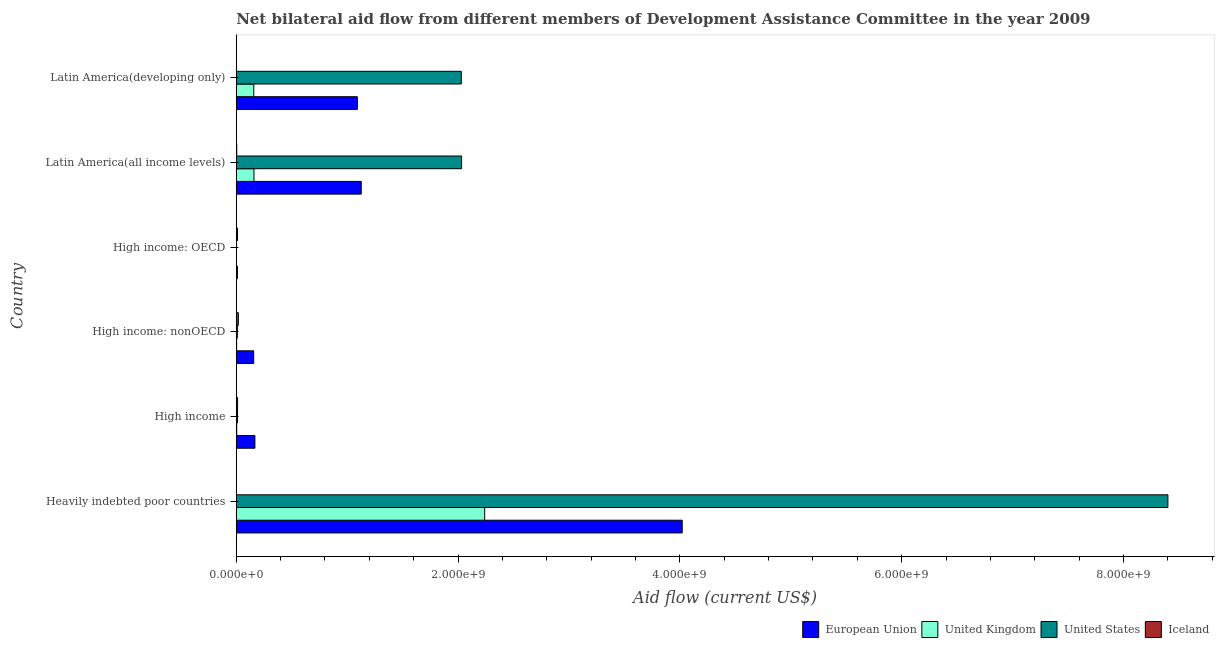Are the number of bars per tick equal to the number of legend labels?
Offer a terse response. Yes. How many bars are there on the 2nd tick from the bottom?
Ensure brevity in your answer.  4. What is the label of the 6th group of bars from the top?
Give a very brief answer. Heavily indebted poor countries. What is the amount of aid given by uk in High income?
Your answer should be very brief. 4.25e+06. Across all countries, what is the maximum amount of aid given by uk?
Offer a terse response. 2.24e+09. Across all countries, what is the minimum amount of aid given by uk?
Your response must be concise. 5.90e+05. In which country was the amount of aid given by eu maximum?
Ensure brevity in your answer.  Heavily indebted poor countries. In which country was the amount of aid given by eu minimum?
Provide a short and direct response. High income: OECD. What is the total amount of aid given by eu in the graph?
Provide a succinct answer. 6.58e+09. What is the difference between the amount of aid given by iceland in Heavily indebted poor countries and that in Latin America(developing only)?
Provide a succinct answer. 2.30e+05. What is the difference between the amount of aid given by eu in High income: nonOECD and the amount of aid given by us in Latin America(developing only)?
Give a very brief answer. -1.87e+09. What is the average amount of aid given by uk per country?
Offer a terse response. 4.28e+08. What is the difference between the amount of aid given by eu and amount of aid given by iceland in High income: nonOECD?
Ensure brevity in your answer.  1.38e+08. In how many countries, is the amount of aid given by eu greater than 1200000000 US$?
Your response must be concise. 1. What is the ratio of the amount of aid given by uk in High income to that in High income: nonOECD?
Your answer should be compact. 1.23. Is the amount of aid given by eu in High income less than that in Latin America(all income levels)?
Provide a short and direct response. Yes. What is the difference between the highest and the second highest amount of aid given by us?
Provide a short and direct response. 6.37e+09. What is the difference between the highest and the lowest amount of aid given by iceland?
Your answer should be compact. 1.76e+07. In how many countries, is the amount of aid given by iceland greater than the average amount of aid given by iceland taken over all countries?
Give a very brief answer. 3. Is the sum of the amount of aid given by us in Heavily indebted poor countries and Latin America(developing only) greater than the maximum amount of aid given by iceland across all countries?
Your answer should be very brief. Yes. What does the 3rd bar from the top in Latin America(developing only) represents?
Your answer should be compact. United Kingdom. Is it the case that in every country, the sum of the amount of aid given by eu and amount of aid given by uk is greater than the amount of aid given by us?
Your response must be concise. No. Are all the bars in the graph horizontal?
Ensure brevity in your answer.  Yes. How many countries are there in the graph?
Offer a very short reply. 6. Are the values on the major ticks of X-axis written in scientific E-notation?
Keep it short and to the point. Yes. Does the graph contain any zero values?
Ensure brevity in your answer.  No. Where does the legend appear in the graph?
Your answer should be very brief. Bottom right. How many legend labels are there?
Your response must be concise. 4. How are the legend labels stacked?
Provide a succinct answer. Horizontal. What is the title of the graph?
Ensure brevity in your answer.  Net bilateral aid flow from different members of Development Assistance Committee in the year 2009. What is the label or title of the Y-axis?
Give a very brief answer. Country. What is the Aid flow (current US$) of European Union in Heavily indebted poor countries?
Provide a succinct answer. 4.02e+09. What is the Aid flow (current US$) in United Kingdom in Heavily indebted poor countries?
Make the answer very short. 2.24e+09. What is the Aid flow (current US$) of United States in Heavily indebted poor countries?
Your answer should be compact. 8.40e+09. What is the Aid flow (current US$) of Iceland in Heavily indebted poor countries?
Provide a succinct answer. 1.67e+06. What is the Aid flow (current US$) in European Union in High income?
Provide a short and direct response. 1.68e+08. What is the Aid flow (current US$) of United Kingdom in High income?
Your answer should be compact. 4.25e+06. What is the Aid flow (current US$) of United States in High income?
Provide a short and direct response. 1.17e+07. What is the Aid flow (current US$) in Iceland in High income?
Keep it short and to the point. 1.21e+07. What is the Aid flow (current US$) of European Union in High income: nonOECD?
Your answer should be compact. 1.57e+08. What is the Aid flow (current US$) in United Kingdom in High income: nonOECD?
Keep it short and to the point. 3.45e+06. What is the Aid flow (current US$) in United States in High income: nonOECD?
Your answer should be very brief. 9.86e+06. What is the Aid flow (current US$) of Iceland in High income: nonOECD?
Give a very brief answer. 1.90e+07. What is the Aid flow (current US$) of European Union in High income: OECD?
Your answer should be compact. 1.08e+07. What is the Aid flow (current US$) of United Kingdom in High income: OECD?
Offer a terse response. 5.90e+05. What is the Aid flow (current US$) of United States in High income: OECD?
Give a very brief answer. 1.84e+06. What is the Aid flow (current US$) of Iceland in High income: OECD?
Keep it short and to the point. 1.17e+07. What is the Aid flow (current US$) of European Union in Latin America(all income levels)?
Provide a short and direct response. 1.13e+09. What is the Aid flow (current US$) in United Kingdom in Latin America(all income levels)?
Make the answer very short. 1.60e+08. What is the Aid flow (current US$) in United States in Latin America(all income levels)?
Your response must be concise. 2.03e+09. What is the Aid flow (current US$) of Iceland in Latin America(all income levels)?
Ensure brevity in your answer.  4.28e+06. What is the Aid flow (current US$) of European Union in Latin America(developing only)?
Offer a terse response. 1.09e+09. What is the Aid flow (current US$) of United Kingdom in Latin America(developing only)?
Give a very brief answer. 1.58e+08. What is the Aid flow (current US$) of United States in Latin America(developing only)?
Your response must be concise. 2.03e+09. What is the Aid flow (current US$) of Iceland in Latin America(developing only)?
Give a very brief answer. 1.44e+06. Across all countries, what is the maximum Aid flow (current US$) in European Union?
Give a very brief answer. 4.02e+09. Across all countries, what is the maximum Aid flow (current US$) of United Kingdom?
Provide a short and direct response. 2.24e+09. Across all countries, what is the maximum Aid flow (current US$) of United States?
Offer a terse response. 8.40e+09. Across all countries, what is the maximum Aid flow (current US$) of Iceland?
Offer a terse response. 1.90e+07. Across all countries, what is the minimum Aid flow (current US$) in European Union?
Your answer should be very brief. 1.08e+07. Across all countries, what is the minimum Aid flow (current US$) in United Kingdom?
Offer a terse response. 5.90e+05. Across all countries, what is the minimum Aid flow (current US$) in United States?
Give a very brief answer. 1.84e+06. Across all countries, what is the minimum Aid flow (current US$) in Iceland?
Provide a short and direct response. 1.44e+06. What is the total Aid flow (current US$) of European Union in the graph?
Give a very brief answer. 6.58e+09. What is the total Aid flow (current US$) in United Kingdom in the graph?
Provide a succinct answer. 2.57e+09. What is the total Aid flow (current US$) in United States in the graph?
Your answer should be compact. 1.25e+1. What is the total Aid flow (current US$) in Iceland in the graph?
Keep it short and to the point. 5.02e+07. What is the difference between the Aid flow (current US$) in European Union in Heavily indebted poor countries and that in High income?
Your response must be concise. 3.85e+09. What is the difference between the Aid flow (current US$) in United Kingdom in Heavily indebted poor countries and that in High income?
Your answer should be very brief. 2.24e+09. What is the difference between the Aid flow (current US$) of United States in Heavily indebted poor countries and that in High income?
Keep it short and to the point. 8.39e+09. What is the difference between the Aid flow (current US$) of Iceland in Heavily indebted poor countries and that in High income?
Offer a very short reply. -1.04e+07. What is the difference between the Aid flow (current US$) in European Union in Heavily indebted poor countries and that in High income: nonOECD?
Your answer should be very brief. 3.86e+09. What is the difference between the Aid flow (current US$) of United Kingdom in Heavily indebted poor countries and that in High income: nonOECD?
Your response must be concise. 2.24e+09. What is the difference between the Aid flow (current US$) of United States in Heavily indebted poor countries and that in High income: nonOECD?
Ensure brevity in your answer.  8.39e+09. What is the difference between the Aid flow (current US$) in Iceland in Heavily indebted poor countries and that in High income: nonOECD?
Keep it short and to the point. -1.74e+07. What is the difference between the Aid flow (current US$) in European Union in Heavily indebted poor countries and that in High income: OECD?
Provide a succinct answer. 4.01e+09. What is the difference between the Aid flow (current US$) in United Kingdom in Heavily indebted poor countries and that in High income: OECD?
Offer a terse response. 2.24e+09. What is the difference between the Aid flow (current US$) of United States in Heavily indebted poor countries and that in High income: OECD?
Your response must be concise. 8.40e+09. What is the difference between the Aid flow (current US$) in Iceland in Heavily indebted poor countries and that in High income: OECD?
Your answer should be compact. -9.99e+06. What is the difference between the Aid flow (current US$) in European Union in Heavily indebted poor countries and that in Latin America(all income levels)?
Keep it short and to the point. 2.89e+09. What is the difference between the Aid flow (current US$) in United Kingdom in Heavily indebted poor countries and that in Latin America(all income levels)?
Your response must be concise. 2.08e+09. What is the difference between the Aid flow (current US$) in United States in Heavily indebted poor countries and that in Latin America(all income levels)?
Provide a succinct answer. 6.37e+09. What is the difference between the Aid flow (current US$) in Iceland in Heavily indebted poor countries and that in Latin America(all income levels)?
Your answer should be compact. -2.61e+06. What is the difference between the Aid flow (current US$) of European Union in Heavily indebted poor countries and that in Latin America(developing only)?
Offer a very short reply. 2.93e+09. What is the difference between the Aid flow (current US$) of United Kingdom in Heavily indebted poor countries and that in Latin America(developing only)?
Give a very brief answer. 2.08e+09. What is the difference between the Aid flow (current US$) in United States in Heavily indebted poor countries and that in Latin America(developing only)?
Provide a succinct answer. 6.37e+09. What is the difference between the Aid flow (current US$) of European Union in High income and that in High income: nonOECD?
Ensure brevity in your answer.  1.08e+07. What is the difference between the Aid flow (current US$) in United Kingdom in High income and that in High income: nonOECD?
Offer a terse response. 8.00e+05. What is the difference between the Aid flow (current US$) of United States in High income and that in High income: nonOECD?
Keep it short and to the point. 1.84e+06. What is the difference between the Aid flow (current US$) of Iceland in High income and that in High income: nonOECD?
Offer a terse response. -6.97e+06. What is the difference between the Aid flow (current US$) of European Union in High income and that in High income: OECD?
Your answer should be compact. 1.57e+08. What is the difference between the Aid flow (current US$) in United Kingdom in High income and that in High income: OECD?
Make the answer very short. 3.66e+06. What is the difference between the Aid flow (current US$) of United States in High income and that in High income: OECD?
Provide a short and direct response. 9.86e+06. What is the difference between the Aid flow (current US$) in European Union in High income and that in Latin America(all income levels)?
Give a very brief answer. -9.59e+08. What is the difference between the Aid flow (current US$) in United Kingdom in High income and that in Latin America(all income levels)?
Provide a succinct answer. -1.55e+08. What is the difference between the Aid flow (current US$) in United States in High income and that in Latin America(all income levels)?
Offer a very short reply. -2.02e+09. What is the difference between the Aid flow (current US$) in Iceland in High income and that in Latin America(all income levels)?
Your response must be concise. 7.79e+06. What is the difference between the Aid flow (current US$) in European Union in High income and that in Latin America(developing only)?
Provide a short and direct response. -9.24e+08. What is the difference between the Aid flow (current US$) in United Kingdom in High income and that in Latin America(developing only)?
Offer a terse response. -1.54e+08. What is the difference between the Aid flow (current US$) in United States in High income and that in Latin America(developing only)?
Make the answer very short. -2.02e+09. What is the difference between the Aid flow (current US$) in Iceland in High income and that in Latin America(developing only)?
Your answer should be very brief. 1.06e+07. What is the difference between the Aid flow (current US$) of European Union in High income: nonOECD and that in High income: OECD?
Offer a very short reply. 1.47e+08. What is the difference between the Aid flow (current US$) of United Kingdom in High income: nonOECD and that in High income: OECD?
Your response must be concise. 2.86e+06. What is the difference between the Aid flow (current US$) in United States in High income: nonOECD and that in High income: OECD?
Offer a very short reply. 8.02e+06. What is the difference between the Aid flow (current US$) in Iceland in High income: nonOECD and that in High income: OECD?
Your response must be concise. 7.38e+06. What is the difference between the Aid flow (current US$) of European Union in High income: nonOECD and that in Latin America(all income levels)?
Give a very brief answer. -9.70e+08. What is the difference between the Aid flow (current US$) of United Kingdom in High income: nonOECD and that in Latin America(all income levels)?
Offer a very short reply. -1.56e+08. What is the difference between the Aid flow (current US$) in United States in High income: nonOECD and that in Latin America(all income levels)?
Offer a very short reply. -2.02e+09. What is the difference between the Aid flow (current US$) of Iceland in High income: nonOECD and that in Latin America(all income levels)?
Give a very brief answer. 1.48e+07. What is the difference between the Aid flow (current US$) in European Union in High income: nonOECD and that in Latin America(developing only)?
Offer a terse response. -9.35e+08. What is the difference between the Aid flow (current US$) in United Kingdom in High income: nonOECD and that in Latin America(developing only)?
Offer a terse response. -1.55e+08. What is the difference between the Aid flow (current US$) in United States in High income: nonOECD and that in Latin America(developing only)?
Give a very brief answer. -2.02e+09. What is the difference between the Aid flow (current US$) of Iceland in High income: nonOECD and that in Latin America(developing only)?
Your answer should be very brief. 1.76e+07. What is the difference between the Aid flow (current US$) of European Union in High income: OECD and that in Latin America(all income levels)?
Your response must be concise. -1.12e+09. What is the difference between the Aid flow (current US$) of United Kingdom in High income: OECD and that in Latin America(all income levels)?
Provide a succinct answer. -1.59e+08. What is the difference between the Aid flow (current US$) in United States in High income: OECD and that in Latin America(all income levels)?
Provide a short and direct response. -2.03e+09. What is the difference between the Aid flow (current US$) of Iceland in High income: OECD and that in Latin America(all income levels)?
Your answer should be compact. 7.38e+06. What is the difference between the Aid flow (current US$) in European Union in High income: OECD and that in Latin America(developing only)?
Offer a very short reply. -1.08e+09. What is the difference between the Aid flow (current US$) of United Kingdom in High income: OECD and that in Latin America(developing only)?
Give a very brief answer. -1.57e+08. What is the difference between the Aid flow (current US$) in United States in High income: OECD and that in Latin America(developing only)?
Provide a succinct answer. -2.03e+09. What is the difference between the Aid flow (current US$) in Iceland in High income: OECD and that in Latin America(developing only)?
Ensure brevity in your answer.  1.02e+07. What is the difference between the Aid flow (current US$) of European Union in Latin America(all income levels) and that in Latin America(developing only)?
Give a very brief answer. 3.50e+07. What is the difference between the Aid flow (current US$) of United Kingdom in Latin America(all income levels) and that in Latin America(developing only)?
Make the answer very short. 1.74e+06. What is the difference between the Aid flow (current US$) of United States in Latin America(all income levels) and that in Latin America(developing only)?
Keep it short and to the point. 2.58e+06. What is the difference between the Aid flow (current US$) in Iceland in Latin America(all income levels) and that in Latin America(developing only)?
Offer a terse response. 2.84e+06. What is the difference between the Aid flow (current US$) of European Union in Heavily indebted poor countries and the Aid flow (current US$) of United Kingdom in High income?
Provide a short and direct response. 4.02e+09. What is the difference between the Aid flow (current US$) of European Union in Heavily indebted poor countries and the Aid flow (current US$) of United States in High income?
Make the answer very short. 4.01e+09. What is the difference between the Aid flow (current US$) of European Union in Heavily indebted poor countries and the Aid flow (current US$) of Iceland in High income?
Offer a very short reply. 4.01e+09. What is the difference between the Aid flow (current US$) in United Kingdom in Heavily indebted poor countries and the Aid flow (current US$) in United States in High income?
Your response must be concise. 2.23e+09. What is the difference between the Aid flow (current US$) of United Kingdom in Heavily indebted poor countries and the Aid flow (current US$) of Iceland in High income?
Keep it short and to the point. 2.23e+09. What is the difference between the Aid flow (current US$) of United States in Heavily indebted poor countries and the Aid flow (current US$) of Iceland in High income?
Give a very brief answer. 8.39e+09. What is the difference between the Aid flow (current US$) of European Union in Heavily indebted poor countries and the Aid flow (current US$) of United Kingdom in High income: nonOECD?
Make the answer very short. 4.02e+09. What is the difference between the Aid flow (current US$) in European Union in Heavily indebted poor countries and the Aid flow (current US$) in United States in High income: nonOECD?
Offer a terse response. 4.01e+09. What is the difference between the Aid flow (current US$) in European Union in Heavily indebted poor countries and the Aid flow (current US$) in Iceland in High income: nonOECD?
Your answer should be compact. 4.00e+09. What is the difference between the Aid flow (current US$) in United Kingdom in Heavily indebted poor countries and the Aid flow (current US$) in United States in High income: nonOECD?
Your answer should be very brief. 2.23e+09. What is the difference between the Aid flow (current US$) of United Kingdom in Heavily indebted poor countries and the Aid flow (current US$) of Iceland in High income: nonOECD?
Offer a terse response. 2.22e+09. What is the difference between the Aid flow (current US$) of United States in Heavily indebted poor countries and the Aid flow (current US$) of Iceland in High income: nonOECD?
Offer a terse response. 8.38e+09. What is the difference between the Aid flow (current US$) in European Union in Heavily indebted poor countries and the Aid flow (current US$) in United Kingdom in High income: OECD?
Your response must be concise. 4.02e+09. What is the difference between the Aid flow (current US$) in European Union in Heavily indebted poor countries and the Aid flow (current US$) in United States in High income: OECD?
Keep it short and to the point. 4.02e+09. What is the difference between the Aid flow (current US$) of European Union in Heavily indebted poor countries and the Aid flow (current US$) of Iceland in High income: OECD?
Ensure brevity in your answer.  4.01e+09. What is the difference between the Aid flow (current US$) of United Kingdom in Heavily indebted poor countries and the Aid flow (current US$) of United States in High income: OECD?
Give a very brief answer. 2.24e+09. What is the difference between the Aid flow (current US$) in United Kingdom in Heavily indebted poor countries and the Aid flow (current US$) in Iceland in High income: OECD?
Your response must be concise. 2.23e+09. What is the difference between the Aid flow (current US$) in United States in Heavily indebted poor countries and the Aid flow (current US$) in Iceland in High income: OECD?
Keep it short and to the point. 8.39e+09. What is the difference between the Aid flow (current US$) of European Union in Heavily indebted poor countries and the Aid flow (current US$) of United Kingdom in Latin America(all income levels)?
Ensure brevity in your answer.  3.86e+09. What is the difference between the Aid flow (current US$) of European Union in Heavily indebted poor countries and the Aid flow (current US$) of United States in Latin America(all income levels)?
Your answer should be very brief. 1.99e+09. What is the difference between the Aid flow (current US$) in European Union in Heavily indebted poor countries and the Aid flow (current US$) in Iceland in Latin America(all income levels)?
Ensure brevity in your answer.  4.02e+09. What is the difference between the Aid flow (current US$) of United Kingdom in Heavily indebted poor countries and the Aid flow (current US$) of United States in Latin America(all income levels)?
Provide a succinct answer. 2.08e+08. What is the difference between the Aid flow (current US$) of United Kingdom in Heavily indebted poor countries and the Aid flow (current US$) of Iceland in Latin America(all income levels)?
Provide a succinct answer. 2.24e+09. What is the difference between the Aid flow (current US$) of United States in Heavily indebted poor countries and the Aid flow (current US$) of Iceland in Latin America(all income levels)?
Your answer should be compact. 8.40e+09. What is the difference between the Aid flow (current US$) of European Union in Heavily indebted poor countries and the Aid flow (current US$) of United Kingdom in Latin America(developing only)?
Your answer should be very brief. 3.86e+09. What is the difference between the Aid flow (current US$) in European Union in Heavily indebted poor countries and the Aid flow (current US$) in United States in Latin America(developing only)?
Give a very brief answer. 1.99e+09. What is the difference between the Aid flow (current US$) of European Union in Heavily indebted poor countries and the Aid flow (current US$) of Iceland in Latin America(developing only)?
Offer a terse response. 4.02e+09. What is the difference between the Aid flow (current US$) of United Kingdom in Heavily indebted poor countries and the Aid flow (current US$) of United States in Latin America(developing only)?
Ensure brevity in your answer.  2.11e+08. What is the difference between the Aid flow (current US$) of United Kingdom in Heavily indebted poor countries and the Aid flow (current US$) of Iceland in Latin America(developing only)?
Give a very brief answer. 2.24e+09. What is the difference between the Aid flow (current US$) in United States in Heavily indebted poor countries and the Aid flow (current US$) in Iceland in Latin America(developing only)?
Ensure brevity in your answer.  8.40e+09. What is the difference between the Aid flow (current US$) in European Union in High income and the Aid flow (current US$) in United Kingdom in High income: nonOECD?
Make the answer very short. 1.65e+08. What is the difference between the Aid flow (current US$) of European Union in High income and the Aid flow (current US$) of United States in High income: nonOECD?
Provide a succinct answer. 1.58e+08. What is the difference between the Aid flow (current US$) in European Union in High income and the Aid flow (current US$) in Iceland in High income: nonOECD?
Offer a very short reply. 1.49e+08. What is the difference between the Aid flow (current US$) in United Kingdom in High income and the Aid flow (current US$) in United States in High income: nonOECD?
Your response must be concise. -5.61e+06. What is the difference between the Aid flow (current US$) in United Kingdom in High income and the Aid flow (current US$) in Iceland in High income: nonOECD?
Offer a terse response. -1.48e+07. What is the difference between the Aid flow (current US$) in United States in High income and the Aid flow (current US$) in Iceland in High income: nonOECD?
Ensure brevity in your answer.  -7.34e+06. What is the difference between the Aid flow (current US$) in European Union in High income and the Aid flow (current US$) in United Kingdom in High income: OECD?
Provide a succinct answer. 1.68e+08. What is the difference between the Aid flow (current US$) in European Union in High income and the Aid flow (current US$) in United States in High income: OECD?
Ensure brevity in your answer.  1.66e+08. What is the difference between the Aid flow (current US$) of European Union in High income and the Aid flow (current US$) of Iceland in High income: OECD?
Ensure brevity in your answer.  1.56e+08. What is the difference between the Aid flow (current US$) of United Kingdom in High income and the Aid flow (current US$) of United States in High income: OECD?
Make the answer very short. 2.41e+06. What is the difference between the Aid flow (current US$) in United Kingdom in High income and the Aid flow (current US$) in Iceland in High income: OECD?
Provide a short and direct response. -7.41e+06. What is the difference between the Aid flow (current US$) in United States in High income and the Aid flow (current US$) in Iceland in High income: OECD?
Offer a terse response. 4.00e+04. What is the difference between the Aid flow (current US$) of European Union in High income and the Aid flow (current US$) of United Kingdom in Latin America(all income levels)?
Offer a terse response. 8.38e+06. What is the difference between the Aid flow (current US$) in European Union in High income and the Aid flow (current US$) in United States in Latin America(all income levels)?
Ensure brevity in your answer.  -1.86e+09. What is the difference between the Aid flow (current US$) of European Union in High income and the Aid flow (current US$) of Iceland in Latin America(all income levels)?
Your answer should be compact. 1.64e+08. What is the difference between the Aid flow (current US$) in United Kingdom in High income and the Aid flow (current US$) in United States in Latin America(all income levels)?
Provide a succinct answer. -2.03e+09. What is the difference between the Aid flow (current US$) in United States in High income and the Aid flow (current US$) in Iceland in Latin America(all income levels)?
Provide a succinct answer. 7.42e+06. What is the difference between the Aid flow (current US$) in European Union in High income and the Aid flow (current US$) in United Kingdom in Latin America(developing only)?
Offer a terse response. 1.01e+07. What is the difference between the Aid flow (current US$) of European Union in High income and the Aid flow (current US$) of United States in Latin America(developing only)?
Your answer should be very brief. -1.86e+09. What is the difference between the Aid flow (current US$) in European Union in High income and the Aid flow (current US$) in Iceland in Latin America(developing only)?
Your answer should be very brief. 1.67e+08. What is the difference between the Aid flow (current US$) of United Kingdom in High income and the Aid flow (current US$) of United States in Latin America(developing only)?
Give a very brief answer. -2.02e+09. What is the difference between the Aid flow (current US$) in United Kingdom in High income and the Aid flow (current US$) in Iceland in Latin America(developing only)?
Ensure brevity in your answer.  2.81e+06. What is the difference between the Aid flow (current US$) in United States in High income and the Aid flow (current US$) in Iceland in Latin America(developing only)?
Give a very brief answer. 1.03e+07. What is the difference between the Aid flow (current US$) in European Union in High income: nonOECD and the Aid flow (current US$) in United Kingdom in High income: OECD?
Your answer should be compact. 1.57e+08. What is the difference between the Aid flow (current US$) of European Union in High income: nonOECD and the Aid flow (current US$) of United States in High income: OECD?
Offer a terse response. 1.55e+08. What is the difference between the Aid flow (current US$) in European Union in High income: nonOECD and the Aid flow (current US$) in Iceland in High income: OECD?
Give a very brief answer. 1.46e+08. What is the difference between the Aid flow (current US$) of United Kingdom in High income: nonOECD and the Aid flow (current US$) of United States in High income: OECD?
Offer a terse response. 1.61e+06. What is the difference between the Aid flow (current US$) of United Kingdom in High income: nonOECD and the Aid flow (current US$) of Iceland in High income: OECD?
Your answer should be very brief. -8.21e+06. What is the difference between the Aid flow (current US$) of United States in High income: nonOECD and the Aid flow (current US$) of Iceland in High income: OECD?
Ensure brevity in your answer.  -1.80e+06. What is the difference between the Aid flow (current US$) in European Union in High income: nonOECD and the Aid flow (current US$) in United Kingdom in Latin America(all income levels)?
Provide a short and direct response. -2.42e+06. What is the difference between the Aid flow (current US$) of European Union in High income: nonOECD and the Aid flow (current US$) of United States in Latin America(all income levels)?
Offer a very short reply. -1.87e+09. What is the difference between the Aid flow (current US$) in European Union in High income: nonOECD and the Aid flow (current US$) in Iceland in Latin America(all income levels)?
Ensure brevity in your answer.  1.53e+08. What is the difference between the Aid flow (current US$) in United Kingdom in High income: nonOECD and the Aid flow (current US$) in United States in Latin America(all income levels)?
Provide a succinct answer. -2.03e+09. What is the difference between the Aid flow (current US$) in United Kingdom in High income: nonOECD and the Aid flow (current US$) in Iceland in Latin America(all income levels)?
Your answer should be very brief. -8.30e+05. What is the difference between the Aid flow (current US$) in United States in High income: nonOECD and the Aid flow (current US$) in Iceland in Latin America(all income levels)?
Your answer should be compact. 5.58e+06. What is the difference between the Aid flow (current US$) in European Union in High income: nonOECD and the Aid flow (current US$) in United Kingdom in Latin America(developing only)?
Keep it short and to the point. -6.80e+05. What is the difference between the Aid flow (current US$) in European Union in High income: nonOECD and the Aid flow (current US$) in United States in Latin America(developing only)?
Ensure brevity in your answer.  -1.87e+09. What is the difference between the Aid flow (current US$) of European Union in High income: nonOECD and the Aid flow (current US$) of Iceland in Latin America(developing only)?
Keep it short and to the point. 1.56e+08. What is the difference between the Aid flow (current US$) of United Kingdom in High income: nonOECD and the Aid flow (current US$) of United States in Latin America(developing only)?
Ensure brevity in your answer.  -2.03e+09. What is the difference between the Aid flow (current US$) of United Kingdom in High income: nonOECD and the Aid flow (current US$) of Iceland in Latin America(developing only)?
Provide a succinct answer. 2.01e+06. What is the difference between the Aid flow (current US$) in United States in High income: nonOECD and the Aid flow (current US$) in Iceland in Latin America(developing only)?
Offer a terse response. 8.42e+06. What is the difference between the Aid flow (current US$) of European Union in High income: OECD and the Aid flow (current US$) of United Kingdom in Latin America(all income levels)?
Provide a short and direct response. -1.49e+08. What is the difference between the Aid flow (current US$) of European Union in High income: OECD and the Aid flow (current US$) of United States in Latin America(all income levels)?
Your answer should be compact. -2.02e+09. What is the difference between the Aid flow (current US$) of European Union in High income: OECD and the Aid flow (current US$) of Iceland in Latin America(all income levels)?
Keep it short and to the point. 6.52e+06. What is the difference between the Aid flow (current US$) in United Kingdom in High income: OECD and the Aid flow (current US$) in United States in Latin America(all income levels)?
Your response must be concise. -2.03e+09. What is the difference between the Aid flow (current US$) of United Kingdom in High income: OECD and the Aid flow (current US$) of Iceland in Latin America(all income levels)?
Provide a succinct answer. -3.69e+06. What is the difference between the Aid flow (current US$) in United States in High income: OECD and the Aid flow (current US$) in Iceland in Latin America(all income levels)?
Offer a terse response. -2.44e+06. What is the difference between the Aid flow (current US$) in European Union in High income: OECD and the Aid flow (current US$) in United Kingdom in Latin America(developing only)?
Give a very brief answer. -1.47e+08. What is the difference between the Aid flow (current US$) in European Union in High income: OECD and the Aid flow (current US$) in United States in Latin America(developing only)?
Offer a terse response. -2.02e+09. What is the difference between the Aid flow (current US$) of European Union in High income: OECD and the Aid flow (current US$) of Iceland in Latin America(developing only)?
Offer a terse response. 9.36e+06. What is the difference between the Aid flow (current US$) in United Kingdom in High income: OECD and the Aid flow (current US$) in United States in Latin America(developing only)?
Make the answer very short. -2.03e+09. What is the difference between the Aid flow (current US$) in United Kingdom in High income: OECD and the Aid flow (current US$) in Iceland in Latin America(developing only)?
Offer a very short reply. -8.50e+05. What is the difference between the Aid flow (current US$) of United States in High income: OECD and the Aid flow (current US$) of Iceland in Latin America(developing only)?
Your answer should be compact. 4.00e+05. What is the difference between the Aid flow (current US$) in European Union in Latin America(all income levels) and the Aid flow (current US$) in United Kingdom in Latin America(developing only)?
Your answer should be compact. 9.69e+08. What is the difference between the Aid flow (current US$) of European Union in Latin America(all income levels) and the Aid flow (current US$) of United States in Latin America(developing only)?
Ensure brevity in your answer.  -9.02e+08. What is the difference between the Aid flow (current US$) in European Union in Latin America(all income levels) and the Aid flow (current US$) in Iceland in Latin America(developing only)?
Keep it short and to the point. 1.13e+09. What is the difference between the Aid flow (current US$) of United Kingdom in Latin America(all income levels) and the Aid flow (current US$) of United States in Latin America(developing only)?
Your answer should be compact. -1.87e+09. What is the difference between the Aid flow (current US$) of United Kingdom in Latin America(all income levels) and the Aid flow (current US$) of Iceland in Latin America(developing only)?
Offer a very short reply. 1.58e+08. What is the difference between the Aid flow (current US$) in United States in Latin America(all income levels) and the Aid flow (current US$) in Iceland in Latin America(developing only)?
Offer a terse response. 2.03e+09. What is the average Aid flow (current US$) of European Union per country?
Make the answer very short. 1.10e+09. What is the average Aid flow (current US$) of United Kingdom per country?
Your response must be concise. 4.28e+08. What is the average Aid flow (current US$) in United States per country?
Provide a short and direct response. 2.08e+09. What is the average Aid flow (current US$) in Iceland per country?
Make the answer very short. 8.36e+06. What is the difference between the Aid flow (current US$) in European Union and Aid flow (current US$) in United Kingdom in Heavily indebted poor countries?
Provide a succinct answer. 1.78e+09. What is the difference between the Aid flow (current US$) of European Union and Aid flow (current US$) of United States in Heavily indebted poor countries?
Your answer should be compact. -4.38e+09. What is the difference between the Aid flow (current US$) in European Union and Aid flow (current US$) in Iceland in Heavily indebted poor countries?
Offer a very short reply. 4.02e+09. What is the difference between the Aid flow (current US$) of United Kingdom and Aid flow (current US$) of United States in Heavily indebted poor countries?
Your answer should be compact. -6.16e+09. What is the difference between the Aid flow (current US$) of United Kingdom and Aid flow (current US$) of Iceland in Heavily indebted poor countries?
Give a very brief answer. 2.24e+09. What is the difference between the Aid flow (current US$) in United States and Aid flow (current US$) in Iceland in Heavily indebted poor countries?
Your response must be concise. 8.40e+09. What is the difference between the Aid flow (current US$) in European Union and Aid flow (current US$) in United Kingdom in High income?
Offer a terse response. 1.64e+08. What is the difference between the Aid flow (current US$) in European Union and Aid flow (current US$) in United States in High income?
Your answer should be very brief. 1.56e+08. What is the difference between the Aid flow (current US$) in European Union and Aid flow (current US$) in Iceland in High income?
Offer a terse response. 1.56e+08. What is the difference between the Aid flow (current US$) of United Kingdom and Aid flow (current US$) of United States in High income?
Ensure brevity in your answer.  -7.45e+06. What is the difference between the Aid flow (current US$) in United Kingdom and Aid flow (current US$) in Iceland in High income?
Give a very brief answer. -7.82e+06. What is the difference between the Aid flow (current US$) in United States and Aid flow (current US$) in Iceland in High income?
Provide a succinct answer. -3.70e+05. What is the difference between the Aid flow (current US$) of European Union and Aid flow (current US$) of United Kingdom in High income: nonOECD?
Your answer should be very brief. 1.54e+08. What is the difference between the Aid flow (current US$) in European Union and Aid flow (current US$) in United States in High income: nonOECD?
Your answer should be compact. 1.47e+08. What is the difference between the Aid flow (current US$) of European Union and Aid flow (current US$) of Iceland in High income: nonOECD?
Make the answer very short. 1.38e+08. What is the difference between the Aid flow (current US$) of United Kingdom and Aid flow (current US$) of United States in High income: nonOECD?
Keep it short and to the point. -6.41e+06. What is the difference between the Aid flow (current US$) of United Kingdom and Aid flow (current US$) of Iceland in High income: nonOECD?
Ensure brevity in your answer.  -1.56e+07. What is the difference between the Aid flow (current US$) of United States and Aid flow (current US$) of Iceland in High income: nonOECD?
Your answer should be very brief. -9.18e+06. What is the difference between the Aid flow (current US$) in European Union and Aid flow (current US$) in United Kingdom in High income: OECD?
Offer a very short reply. 1.02e+07. What is the difference between the Aid flow (current US$) in European Union and Aid flow (current US$) in United States in High income: OECD?
Make the answer very short. 8.96e+06. What is the difference between the Aid flow (current US$) in European Union and Aid flow (current US$) in Iceland in High income: OECD?
Provide a succinct answer. -8.60e+05. What is the difference between the Aid flow (current US$) of United Kingdom and Aid flow (current US$) of United States in High income: OECD?
Your answer should be very brief. -1.25e+06. What is the difference between the Aid flow (current US$) in United Kingdom and Aid flow (current US$) in Iceland in High income: OECD?
Offer a terse response. -1.11e+07. What is the difference between the Aid flow (current US$) in United States and Aid flow (current US$) in Iceland in High income: OECD?
Your answer should be very brief. -9.82e+06. What is the difference between the Aid flow (current US$) of European Union and Aid flow (current US$) of United Kingdom in Latin America(all income levels)?
Offer a terse response. 9.67e+08. What is the difference between the Aid flow (current US$) in European Union and Aid flow (current US$) in United States in Latin America(all income levels)?
Ensure brevity in your answer.  -9.05e+08. What is the difference between the Aid flow (current US$) in European Union and Aid flow (current US$) in Iceland in Latin America(all income levels)?
Your response must be concise. 1.12e+09. What is the difference between the Aid flow (current US$) in United Kingdom and Aid flow (current US$) in United States in Latin America(all income levels)?
Ensure brevity in your answer.  -1.87e+09. What is the difference between the Aid flow (current US$) of United Kingdom and Aid flow (current US$) of Iceland in Latin America(all income levels)?
Your response must be concise. 1.55e+08. What is the difference between the Aid flow (current US$) of United States and Aid flow (current US$) of Iceland in Latin America(all income levels)?
Provide a short and direct response. 2.03e+09. What is the difference between the Aid flow (current US$) in European Union and Aid flow (current US$) in United Kingdom in Latin America(developing only)?
Provide a short and direct response. 9.34e+08. What is the difference between the Aid flow (current US$) in European Union and Aid flow (current US$) in United States in Latin America(developing only)?
Ensure brevity in your answer.  -9.37e+08. What is the difference between the Aid flow (current US$) of European Union and Aid flow (current US$) of Iceland in Latin America(developing only)?
Your response must be concise. 1.09e+09. What is the difference between the Aid flow (current US$) in United Kingdom and Aid flow (current US$) in United States in Latin America(developing only)?
Your answer should be very brief. -1.87e+09. What is the difference between the Aid flow (current US$) of United Kingdom and Aid flow (current US$) of Iceland in Latin America(developing only)?
Make the answer very short. 1.57e+08. What is the difference between the Aid flow (current US$) in United States and Aid flow (current US$) in Iceland in Latin America(developing only)?
Your answer should be compact. 2.03e+09. What is the ratio of the Aid flow (current US$) of European Union in Heavily indebted poor countries to that in High income?
Your answer should be very brief. 23.92. What is the ratio of the Aid flow (current US$) in United Kingdom in Heavily indebted poor countries to that in High income?
Keep it short and to the point. 527.02. What is the ratio of the Aid flow (current US$) of United States in Heavily indebted poor countries to that in High income?
Keep it short and to the point. 717.97. What is the ratio of the Aid flow (current US$) of Iceland in Heavily indebted poor countries to that in High income?
Your response must be concise. 0.14. What is the ratio of the Aid flow (current US$) in European Union in Heavily indebted poor countries to that in High income: nonOECD?
Your answer should be compact. 25.56. What is the ratio of the Aid flow (current US$) of United Kingdom in Heavily indebted poor countries to that in High income: nonOECD?
Ensure brevity in your answer.  649.22. What is the ratio of the Aid flow (current US$) in United States in Heavily indebted poor countries to that in High income: nonOECD?
Offer a terse response. 851.95. What is the ratio of the Aid flow (current US$) of Iceland in Heavily indebted poor countries to that in High income: nonOECD?
Offer a very short reply. 0.09. What is the ratio of the Aid flow (current US$) in European Union in Heavily indebted poor countries to that in High income: OECD?
Provide a short and direct response. 372.31. What is the ratio of the Aid flow (current US$) in United Kingdom in Heavily indebted poor countries to that in High income: OECD?
Your answer should be compact. 3796.31. What is the ratio of the Aid flow (current US$) of United States in Heavily indebted poor countries to that in High income: OECD?
Ensure brevity in your answer.  4565.32. What is the ratio of the Aid flow (current US$) in Iceland in Heavily indebted poor countries to that in High income: OECD?
Your answer should be compact. 0.14. What is the ratio of the Aid flow (current US$) of European Union in Heavily indebted poor countries to that in Latin America(all income levels)?
Ensure brevity in your answer.  3.57. What is the ratio of the Aid flow (current US$) of United Kingdom in Heavily indebted poor countries to that in Latin America(all income levels)?
Ensure brevity in your answer.  14.02. What is the ratio of the Aid flow (current US$) in United States in Heavily indebted poor countries to that in Latin America(all income levels)?
Keep it short and to the point. 4.13. What is the ratio of the Aid flow (current US$) of Iceland in Heavily indebted poor countries to that in Latin America(all income levels)?
Your answer should be compact. 0.39. What is the ratio of the Aid flow (current US$) in European Union in Heavily indebted poor countries to that in Latin America(developing only)?
Make the answer very short. 3.68. What is the ratio of the Aid flow (current US$) of United Kingdom in Heavily indebted poor countries to that in Latin America(developing only)?
Your answer should be compact. 14.18. What is the ratio of the Aid flow (current US$) of United States in Heavily indebted poor countries to that in Latin America(developing only)?
Your answer should be compact. 4.14. What is the ratio of the Aid flow (current US$) in Iceland in Heavily indebted poor countries to that in Latin America(developing only)?
Provide a succinct answer. 1.16. What is the ratio of the Aid flow (current US$) of European Union in High income to that in High income: nonOECD?
Provide a short and direct response. 1.07. What is the ratio of the Aid flow (current US$) of United Kingdom in High income to that in High income: nonOECD?
Offer a terse response. 1.23. What is the ratio of the Aid flow (current US$) in United States in High income to that in High income: nonOECD?
Provide a succinct answer. 1.19. What is the ratio of the Aid flow (current US$) in Iceland in High income to that in High income: nonOECD?
Keep it short and to the point. 0.63. What is the ratio of the Aid flow (current US$) of European Union in High income to that in High income: OECD?
Make the answer very short. 15.57. What is the ratio of the Aid flow (current US$) in United Kingdom in High income to that in High income: OECD?
Your response must be concise. 7.2. What is the ratio of the Aid flow (current US$) in United States in High income to that in High income: OECD?
Your response must be concise. 6.36. What is the ratio of the Aid flow (current US$) of Iceland in High income to that in High income: OECD?
Offer a terse response. 1.04. What is the ratio of the Aid flow (current US$) in European Union in High income to that in Latin America(all income levels)?
Provide a succinct answer. 0.15. What is the ratio of the Aid flow (current US$) of United Kingdom in High income to that in Latin America(all income levels)?
Keep it short and to the point. 0.03. What is the ratio of the Aid flow (current US$) in United States in High income to that in Latin America(all income levels)?
Offer a very short reply. 0.01. What is the ratio of the Aid flow (current US$) of Iceland in High income to that in Latin America(all income levels)?
Give a very brief answer. 2.82. What is the ratio of the Aid flow (current US$) of European Union in High income to that in Latin America(developing only)?
Make the answer very short. 0.15. What is the ratio of the Aid flow (current US$) in United Kingdom in High income to that in Latin America(developing only)?
Provide a succinct answer. 0.03. What is the ratio of the Aid flow (current US$) of United States in High income to that in Latin America(developing only)?
Your answer should be compact. 0.01. What is the ratio of the Aid flow (current US$) of Iceland in High income to that in Latin America(developing only)?
Provide a succinct answer. 8.38. What is the ratio of the Aid flow (current US$) in European Union in High income: nonOECD to that in High income: OECD?
Your answer should be very brief. 14.57. What is the ratio of the Aid flow (current US$) of United Kingdom in High income: nonOECD to that in High income: OECD?
Your answer should be very brief. 5.85. What is the ratio of the Aid flow (current US$) of United States in High income: nonOECD to that in High income: OECD?
Your answer should be compact. 5.36. What is the ratio of the Aid flow (current US$) of Iceland in High income: nonOECD to that in High income: OECD?
Your answer should be very brief. 1.63. What is the ratio of the Aid flow (current US$) of European Union in High income: nonOECD to that in Latin America(all income levels)?
Your answer should be compact. 0.14. What is the ratio of the Aid flow (current US$) in United Kingdom in High income: nonOECD to that in Latin America(all income levels)?
Ensure brevity in your answer.  0.02. What is the ratio of the Aid flow (current US$) in United States in High income: nonOECD to that in Latin America(all income levels)?
Offer a very short reply. 0. What is the ratio of the Aid flow (current US$) of Iceland in High income: nonOECD to that in Latin America(all income levels)?
Make the answer very short. 4.45. What is the ratio of the Aid flow (current US$) of European Union in High income: nonOECD to that in Latin America(developing only)?
Your response must be concise. 0.14. What is the ratio of the Aid flow (current US$) in United Kingdom in High income: nonOECD to that in Latin America(developing only)?
Provide a short and direct response. 0.02. What is the ratio of the Aid flow (current US$) in United States in High income: nonOECD to that in Latin America(developing only)?
Offer a very short reply. 0. What is the ratio of the Aid flow (current US$) of Iceland in High income: nonOECD to that in Latin America(developing only)?
Your answer should be compact. 13.22. What is the ratio of the Aid flow (current US$) of European Union in High income: OECD to that in Latin America(all income levels)?
Your response must be concise. 0.01. What is the ratio of the Aid flow (current US$) of United Kingdom in High income: OECD to that in Latin America(all income levels)?
Your answer should be very brief. 0. What is the ratio of the Aid flow (current US$) in United States in High income: OECD to that in Latin America(all income levels)?
Offer a very short reply. 0. What is the ratio of the Aid flow (current US$) in Iceland in High income: OECD to that in Latin America(all income levels)?
Offer a terse response. 2.72. What is the ratio of the Aid flow (current US$) of European Union in High income: OECD to that in Latin America(developing only)?
Provide a succinct answer. 0.01. What is the ratio of the Aid flow (current US$) of United Kingdom in High income: OECD to that in Latin America(developing only)?
Keep it short and to the point. 0. What is the ratio of the Aid flow (current US$) in United States in High income: OECD to that in Latin America(developing only)?
Your response must be concise. 0. What is the ratio of the Aid flow (current US$) of Iceland in High income: OECD to that in Latin America(developing only)?
Provide a succinct answer. 8.1. What is the ratio of the Aid flow (current US$) of European Union in Latin America(all income levels) to that in Latin America(developing only)?
Keep it short and to the point. 1.03. What is the ratio of the Aid flow (current US$) in United Kingdom in Latin America(all income levels) to that in Latin America(developing only)?
Keep it short and to the point. 1.01. What is the ratio of the Aid flow (current US$) of United States in Latin America(all income levels) to that in Latin America(developing only)?
Keep it short and to the point. 1. What is the ratio of the Aid flow (current US$) in Iceland in Latin America(all income levels) to that in Latin America(developing only)?
Your answer should be very brief. 2.97. What is the difference between the highest and the second highest Aid flow (current US$) in European Union?
Provide a succinct answer. 2.89e+09. What is the difference between the highest and the second highest Aid flow (current US$) in United Kingdom?
Provide a succinct answer. 2.08e+09. What is the difference between the highest and the second highest Aid flow (current US$) of United States?
Ensure brevity in your answer.  6.37e+09. What is the difference between the highest and the second highest Aid flow (current US$) in Iceland?
Your answer should be compact. 6.97e+06. What is the difference between the highest and the lowest Aid flow (current US$) in European Union?
Your response must be concise. 4.01e+09. What is the difference between the highest and the lowest Aid flow (current US$) in United Kingdom?
Your response must be concise. 2.24e+09. What is the difference between the highest and the lowest Aid flow (current US$) of United States?
Ensure brevity in your answer.  8.40e+09. What is the difference between the highest and the lowest Aid flow (current US$) of Iceland?
Provide a short and direct response. 1.76e+07. 